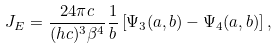<formula> <loc_0><loc_0><loc_500><loc_500>J _ { E } = \frac { 2 4 \pi c } { ( h c ) ^ { 3 } \beta ^ { 4 } } \frac { 1 } { b } \left [ \Psi _ { 3 } ( a , b ) - \Psi _ { 4 } ( a , b ) \right ] ,</formula> 